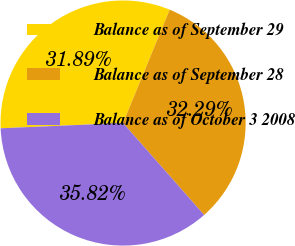<chart> <loc_0><loc_0><loc_500><loc_500><pie_chart><fcel>Balance as of September 29<fcel>Balance as of September 28<fcel>Balance as of October 3 2008<nl><fcel>31.89%<fcel>32.29%<fcel>35.82%<nl></chart> 